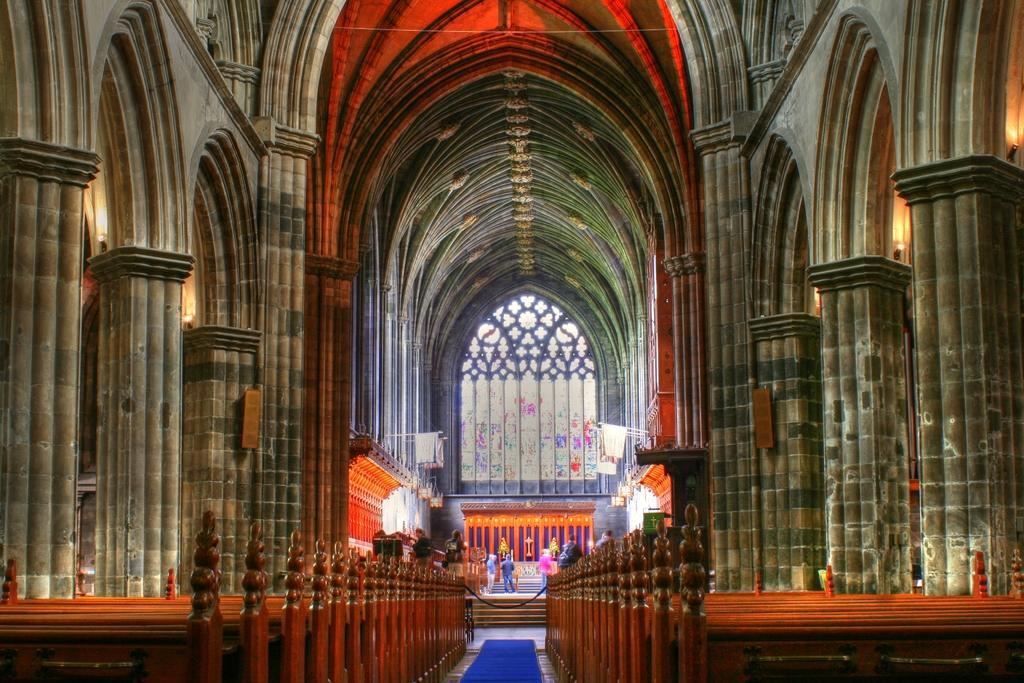Describe this image in one or two sentences. This image seems to be clicked in a church, there are pillar on either side with benches in front of it, in the background there are few people standing in front of the wall with a big glass window over it. 